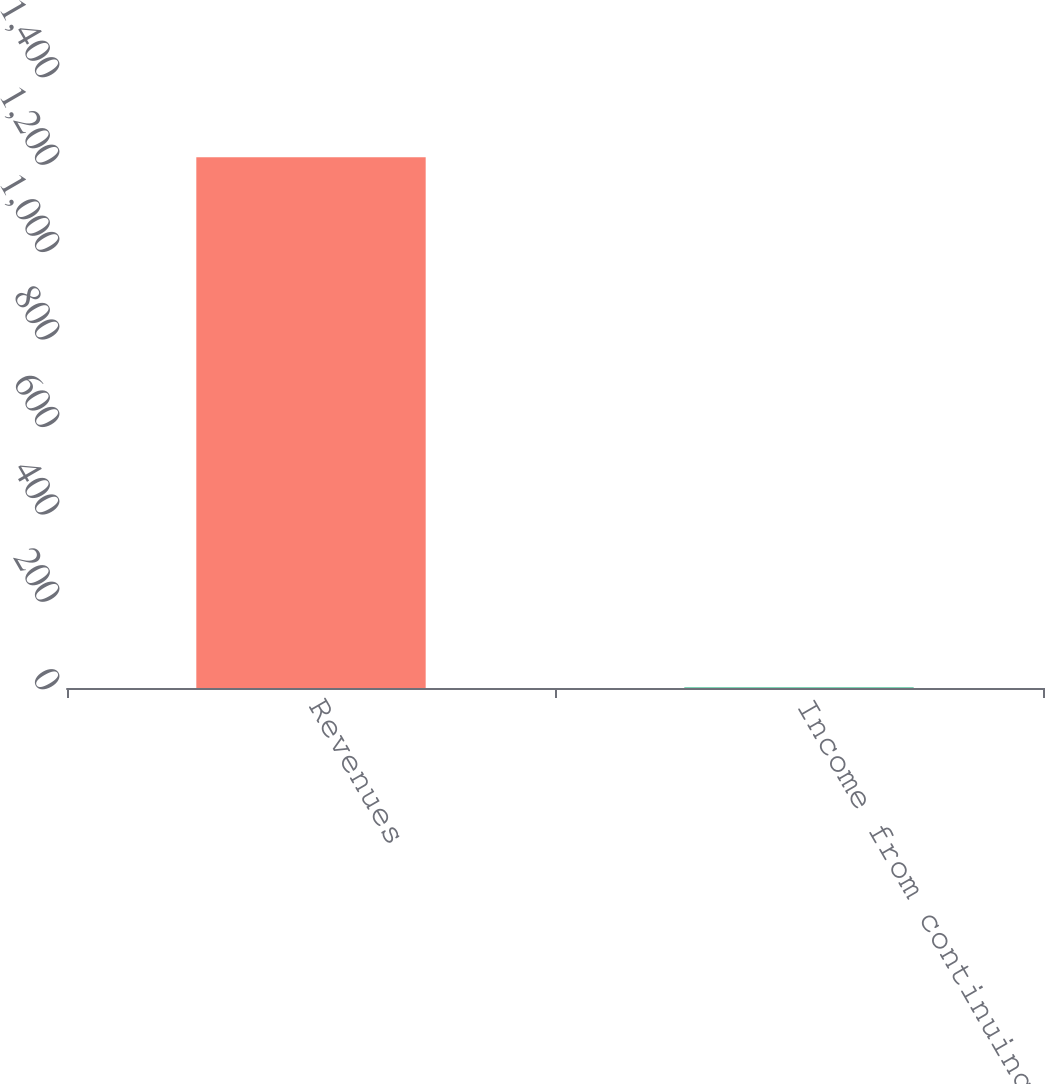<chart> <loc_0><loc_0><loc_500><loc_500><bar_chart><fcel>Revenues<fcel>Income from continuing<nl><fcel>1213.9<fcel>1.32<nl></chart> 